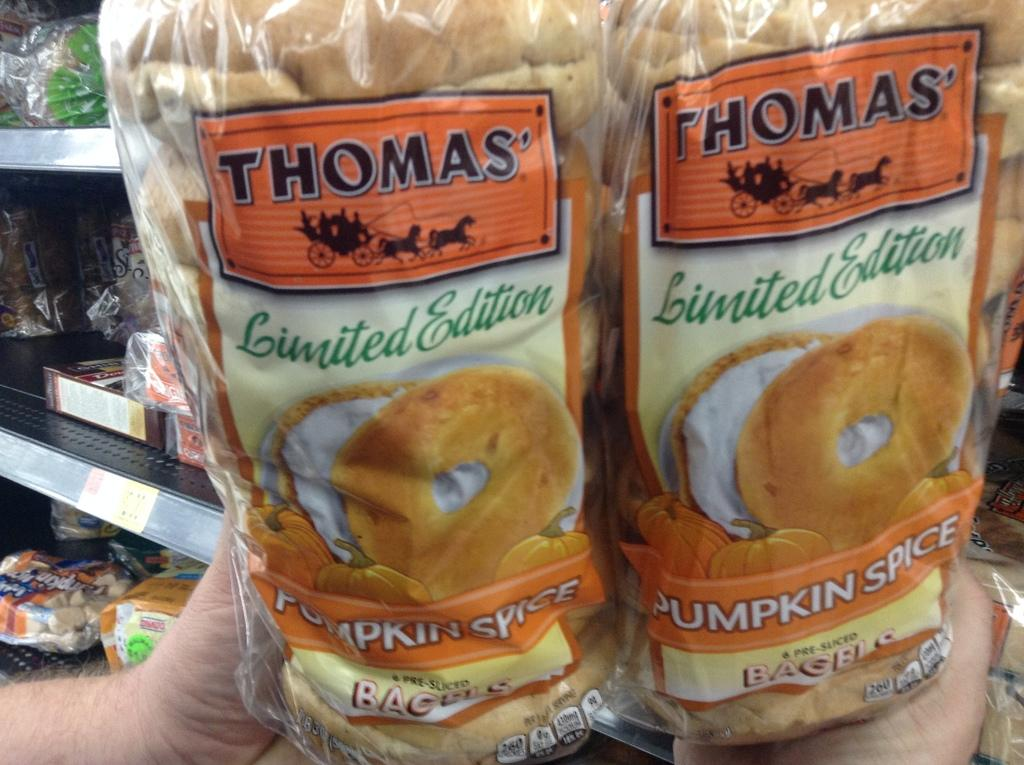What is the person's hand holding in the image? The person's hand is holding two bread packets in the image. How are the bread packets packaged? The bread packets are packed. Where are the food items placed in the image? The food items are placed in the racks. What type of beast can be seen in the image? There is no beast present in the image. What kind of vessel is being used to transport the bread packets? There is no vessel present in the image; the bread packets are held by a person's hand. 